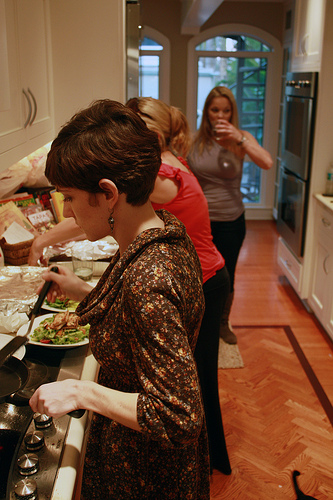Please provide a short description for this region: [0.38, 0.41, 0.4, 0.46]. A long, dangling earring. This box shows an earring that is long and dangles from the ear. 